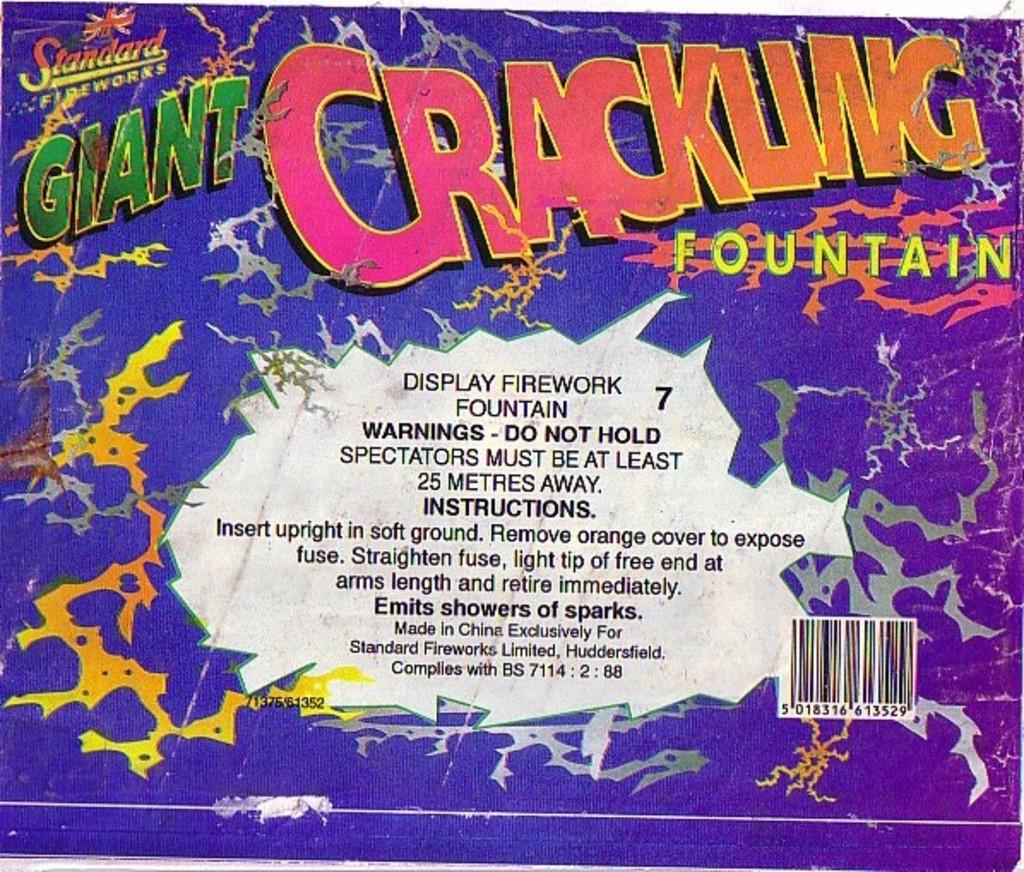What kind of wire work is this?
Give a very brief answer. Giant crackling fountain. Giant cracking what?
Ensure brevity in your answer.  Fountain. 